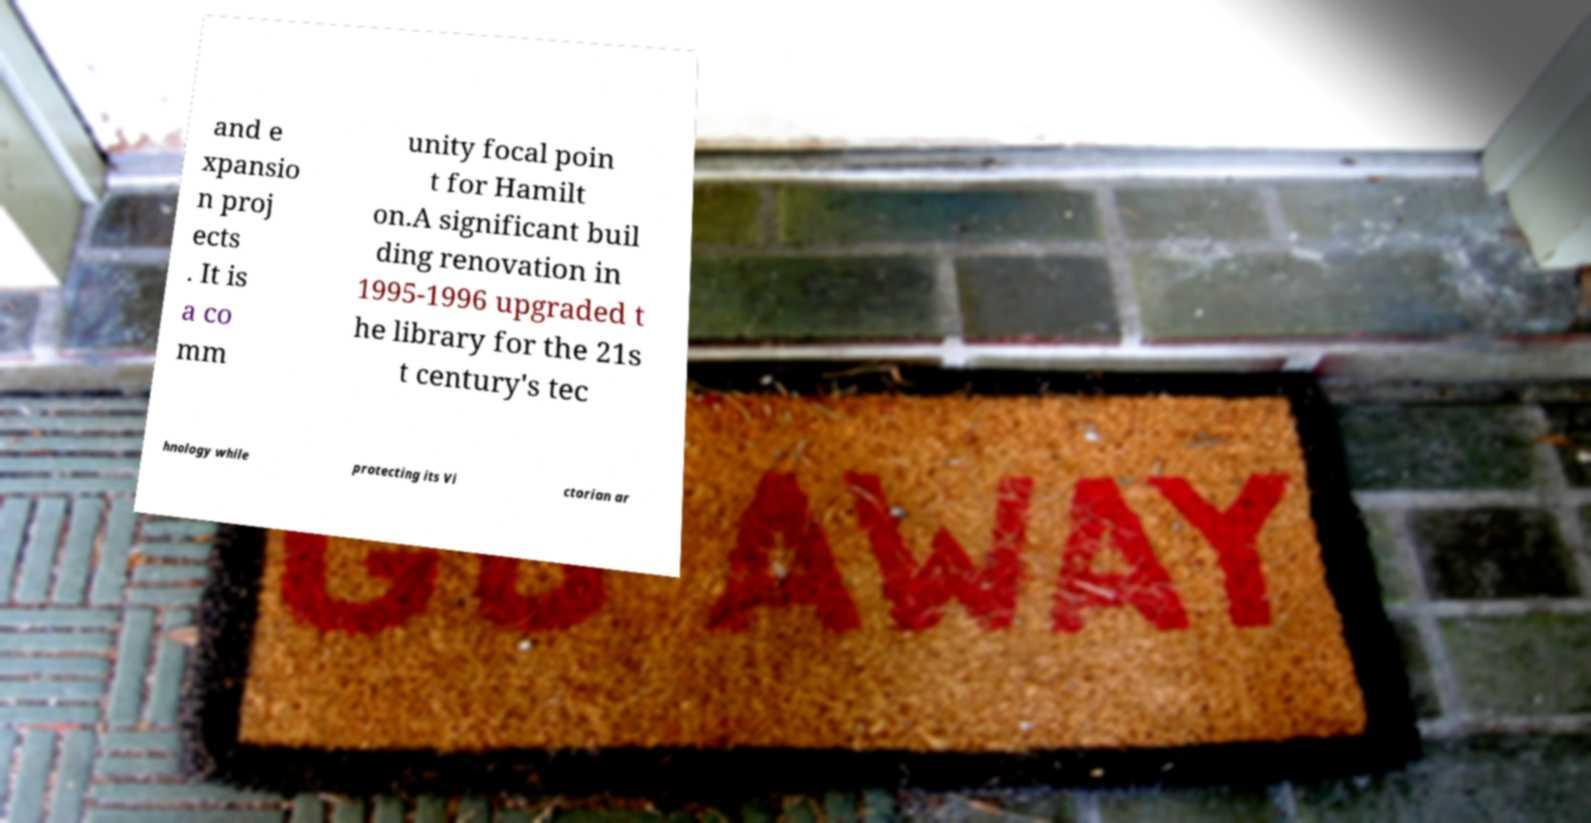I need the written content from this picture converted into text. Can you do that? and e xpansio n proj ects . It is a co mm unity focal poin t for Hamilt on.A significant buil ding renovation in 1995-1996 upgraded t he library for the 21s t century's tec hnology while protecting its Vi ctorian ar 